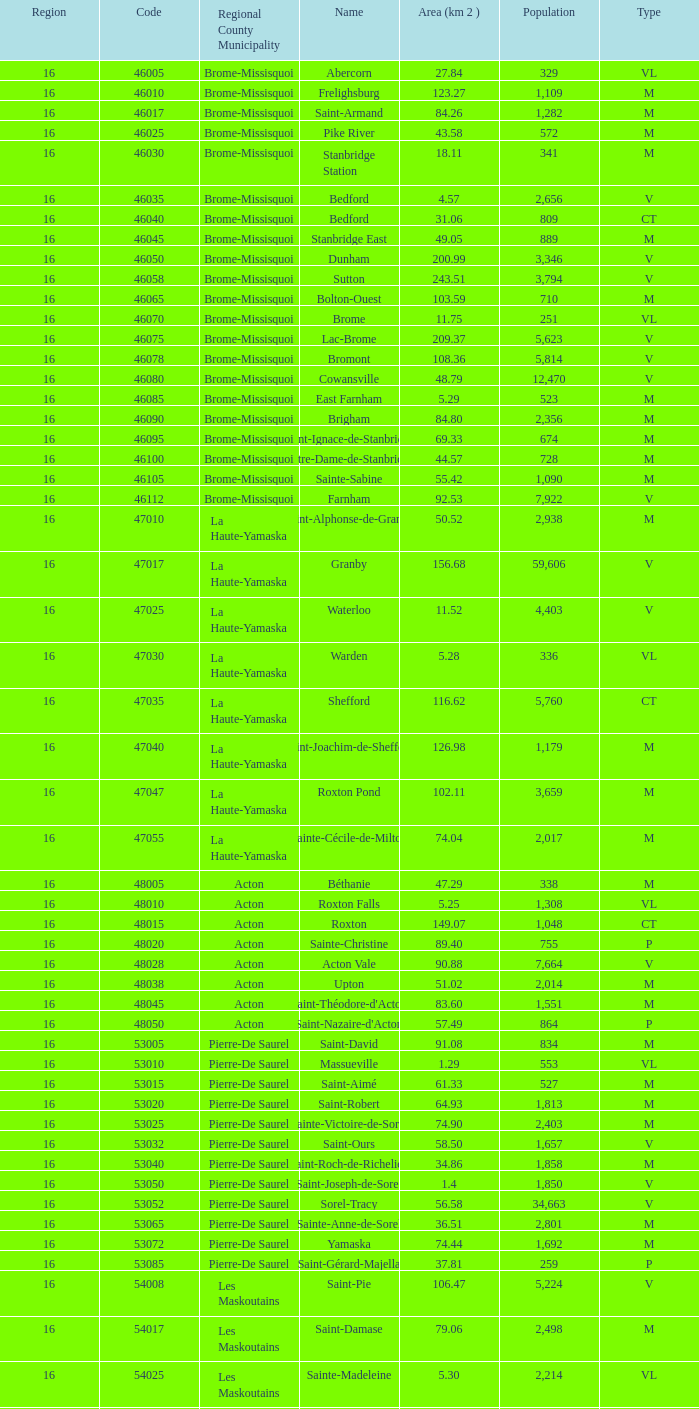What is the code for a Le Haut-Saint-Laurent municipality that has 16 or more regions? None. 